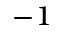Convert formula to latex. <formula><loc_0><loc_0><loc_500><loc_500>^ { - 1 }</formula> 